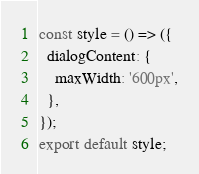<code> <loc_0><loc_0><loc_500><loc_500><_JavaScript_>const style = () => ({
  dialogContent: {
    maxWidth: '600px',
  },
});
export default style;

</code> 